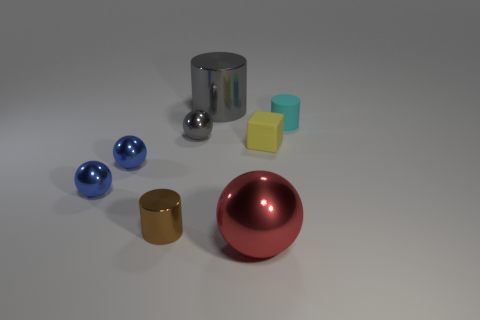Subtract all metallic cylinders. How many cylinders are left? 1 Subtract all gray balls. How many balls are left? 3 Add 1 yellow matte objects. How many objects exist? 9 Subtract 1 cubes. How many cubes are left? 0 Subtract all blue balls. Subtract all gray cylinders. How many balls are left? 2 Subtract all purple cylinders. How many red balls are left? 1 Subtract all large red metallic objects. Subtract all tiny green blocks. How many objects are left? 7 Add 3 large gray shiny cylinders. How many large gray shiny cylinders are left? 4 Add 7 gray things. How many gray things exist? 9 Subtract 0 cyan cubes. How many objects are left? 8 